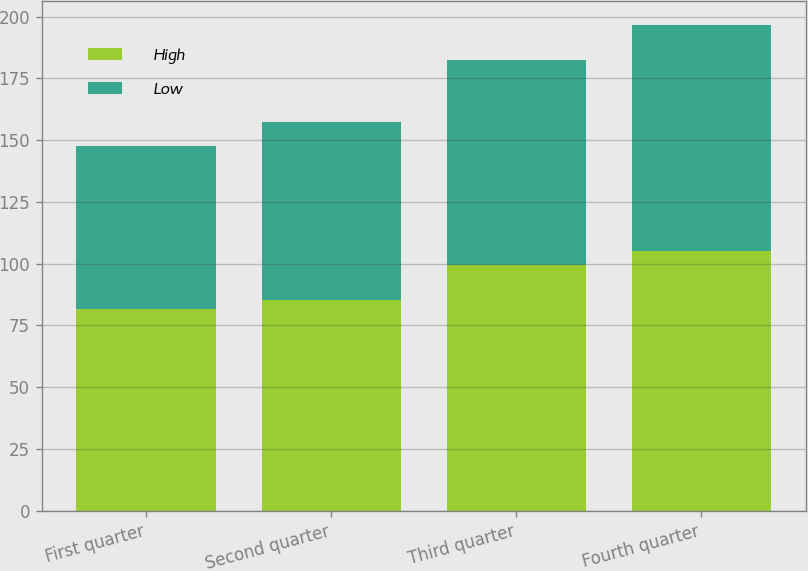<chart> <loc_0><loc_0><loc_500><loc_500><stacked_bar_chart><ecel><fcel>First quarter<fcel>Second quarter<fcel>Third quarter<fcel>Fourth quarter<nl><fcel>High<fcel>81.52<fcel>85.17<fcel>99.6<fcel>105.25<nl><fcel>Low<fcel>66.01<fcel>72.1<fcel>82.93<fcel>91.21<nl></chart> 